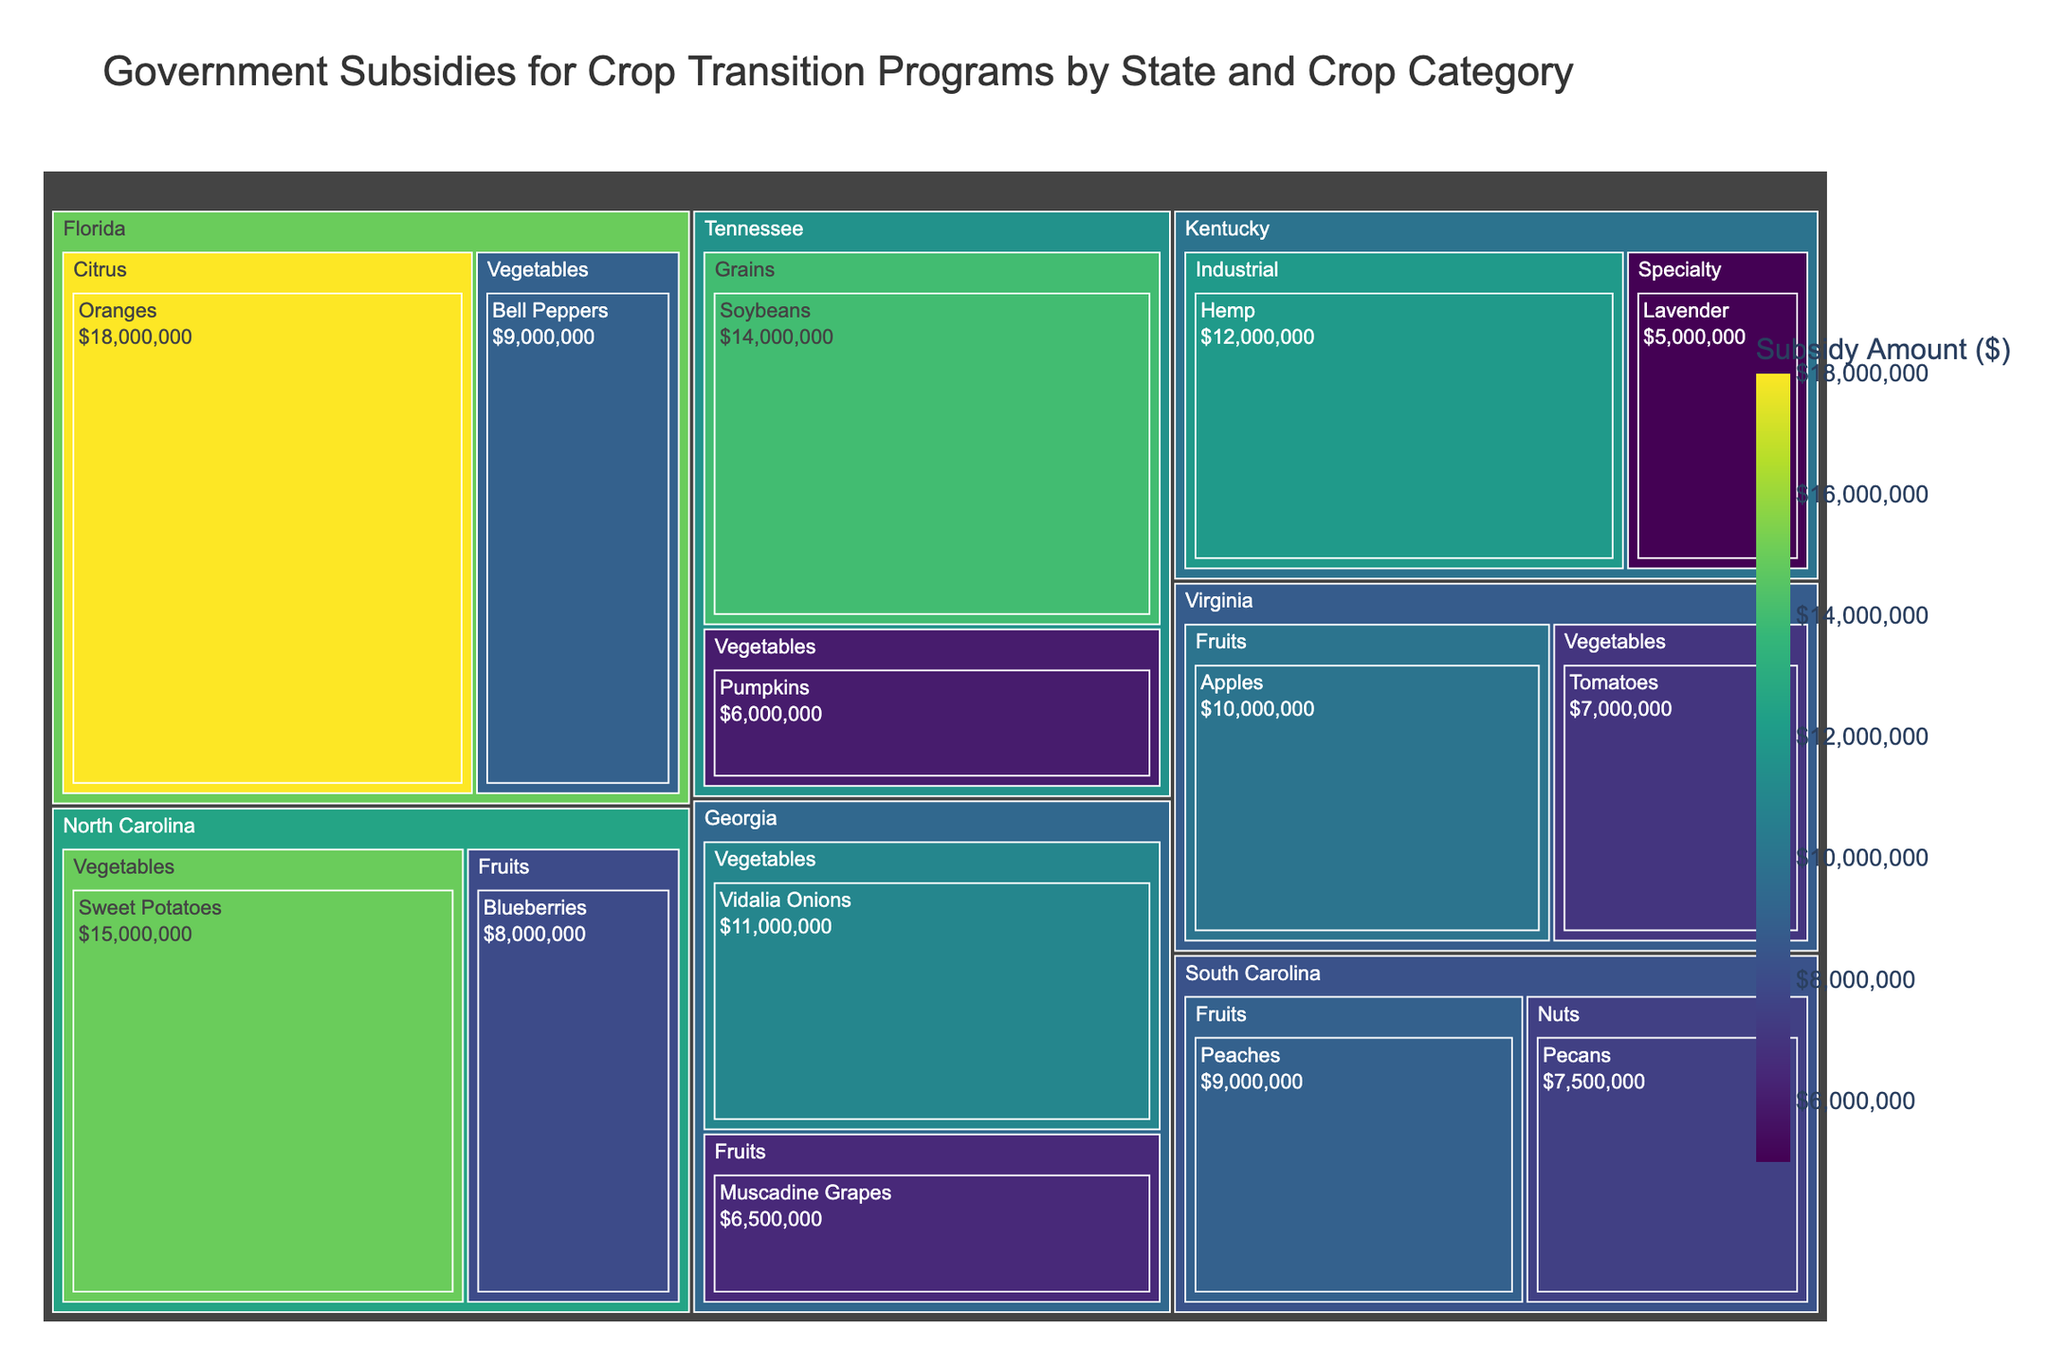what's the title of the treemap? The title is located at the top of the treemap. It summarizes the main purpose and scope of the figure.
Answer: Government Subsidies for Crop Transition Programs by State and Crop Category Which crop category in Florida receives the highest subsidy? In Florida, identify the crop categories and compare their subsidy values.
Answer: Citrus How much subsidy does North Carolina receive for growing Sweet Potatoes? Locate North Carolina, then find the Sweet Potatoes category and read the subsidy value.
Answer: $15,000,000 What is the total subsidy amount for fruits across all states? Identify all the subcategories under Fruits across all states and sum their subsidy values: Blueberries (8000000) + Apples (10000000) + Peaches (9000000) + Muscadine Grapes (6500000) = 33,500,000.
Answer: $33,500,000 Which state has the smallest total subsidy amount? Sum all subsidies for each state and compare the totals to find the smallest.
Answer: South Carolina How do the subsidies for Vegetables in Georgia compare to those in North Carolina? Look at the subsidy amounts for Vegetables in Georgia and North Carolina and compare them. Georgia (Vidalia Onions - 11,000,000); North Carolina (Sweet Potatoes - 15,000,000, Tomatoes - 7,000,000).
Answer: Georgia: $11,000,000; North Carolina: $22,000,000 Which crop receives the highest subsidy in Kentucky? Identify the crops listed under Kentucky and compare their subsidy amounts.
Answer: Hemp What is the combined subsidy amount for Vegetables in North Carolina and Bell Peppers in Florida? Add the subsidy amounts for Vegetables in North Carolina (Sweet Potatoes - 15,000,000, Tomatoes - 7,000,000) and Bell Peppers in Florida (9,000,000).
Answer: $31,000,000 How does the subsidy for Industrial Hemp in Kentucky compare to the subsidy for Soybeans in Tennessee? Compare the subsidy amounts for Industrial Hemp in Kentucky and Soybeans in Tennessee. Hemp (12,000,000); Soybeans (14,000,000).
Answer: Industrial Hemp: $12,000,000; Soybeans: $14,000,000 